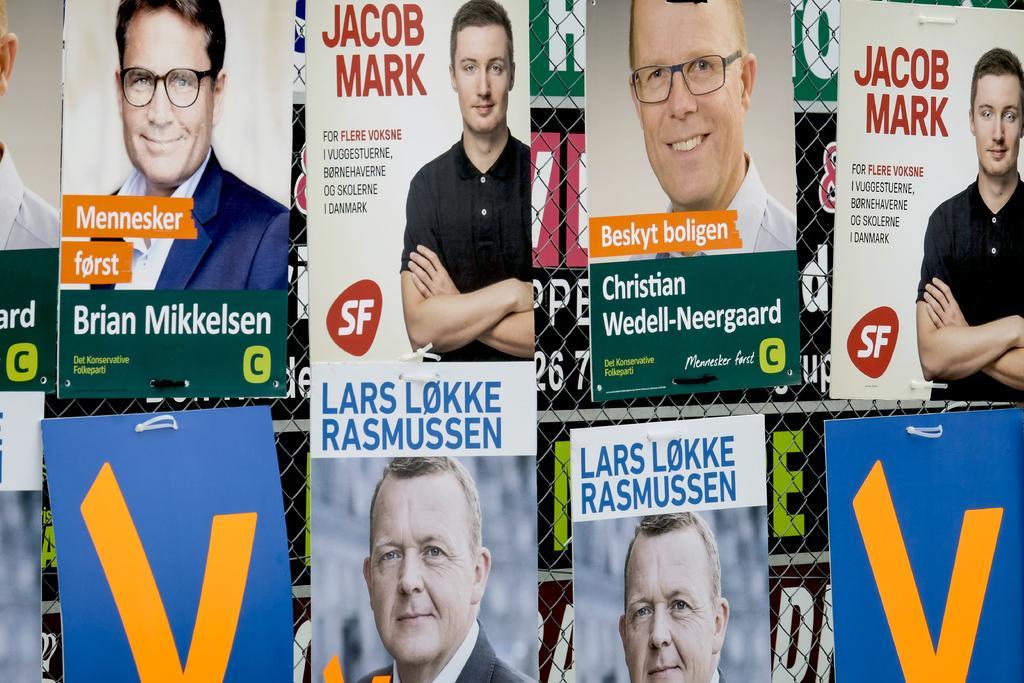Can you describe this image briefly? In this image there are boards with some text and images on it and in the center there is a fence and in the background there are banners with some text written on it. 